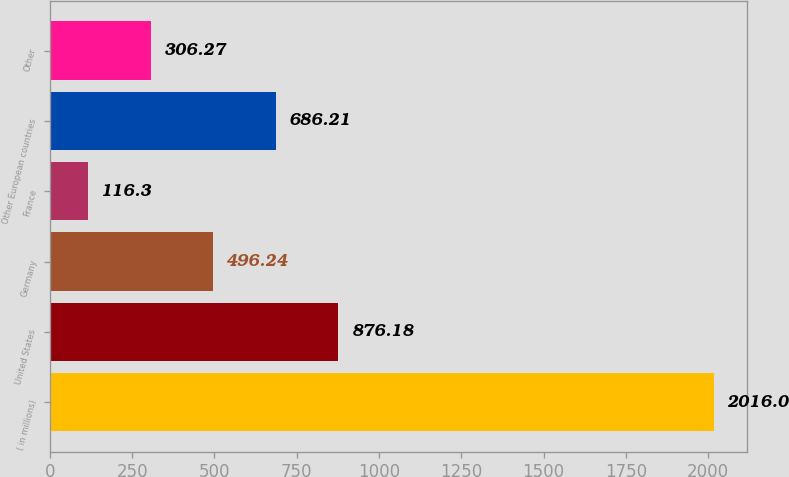<chart> <loc_0><loc_0><loc_500><loc_500><bar_chart><fcel>( in millions)<fcel>United States<fcel>Germany<fcel>France<fcel>Other European countries<fcel>Other<nl><fcel>2016<fcel>876.18<fcel>496.24<fcel>116.3<fcel>686.21<fcel>306.27<nl></chart> 